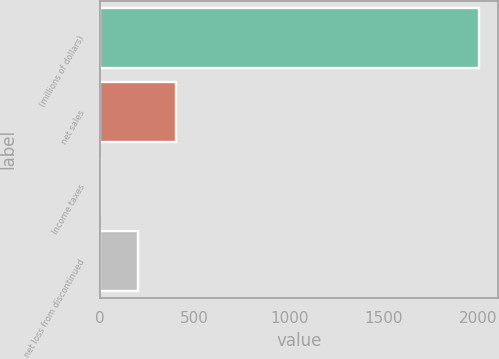Convert chart to OTSL. <chart><loc_0><loc_0><loc_500><loc_500><bar_chart><fcel>(millions of dollars)<fcel>net sales<fcel>Income taxes<fcel>net loss from discontinued<nl><fcel>2005<fcel>401.72<fcel>0.9<fcel>201.31<nl></chart> 